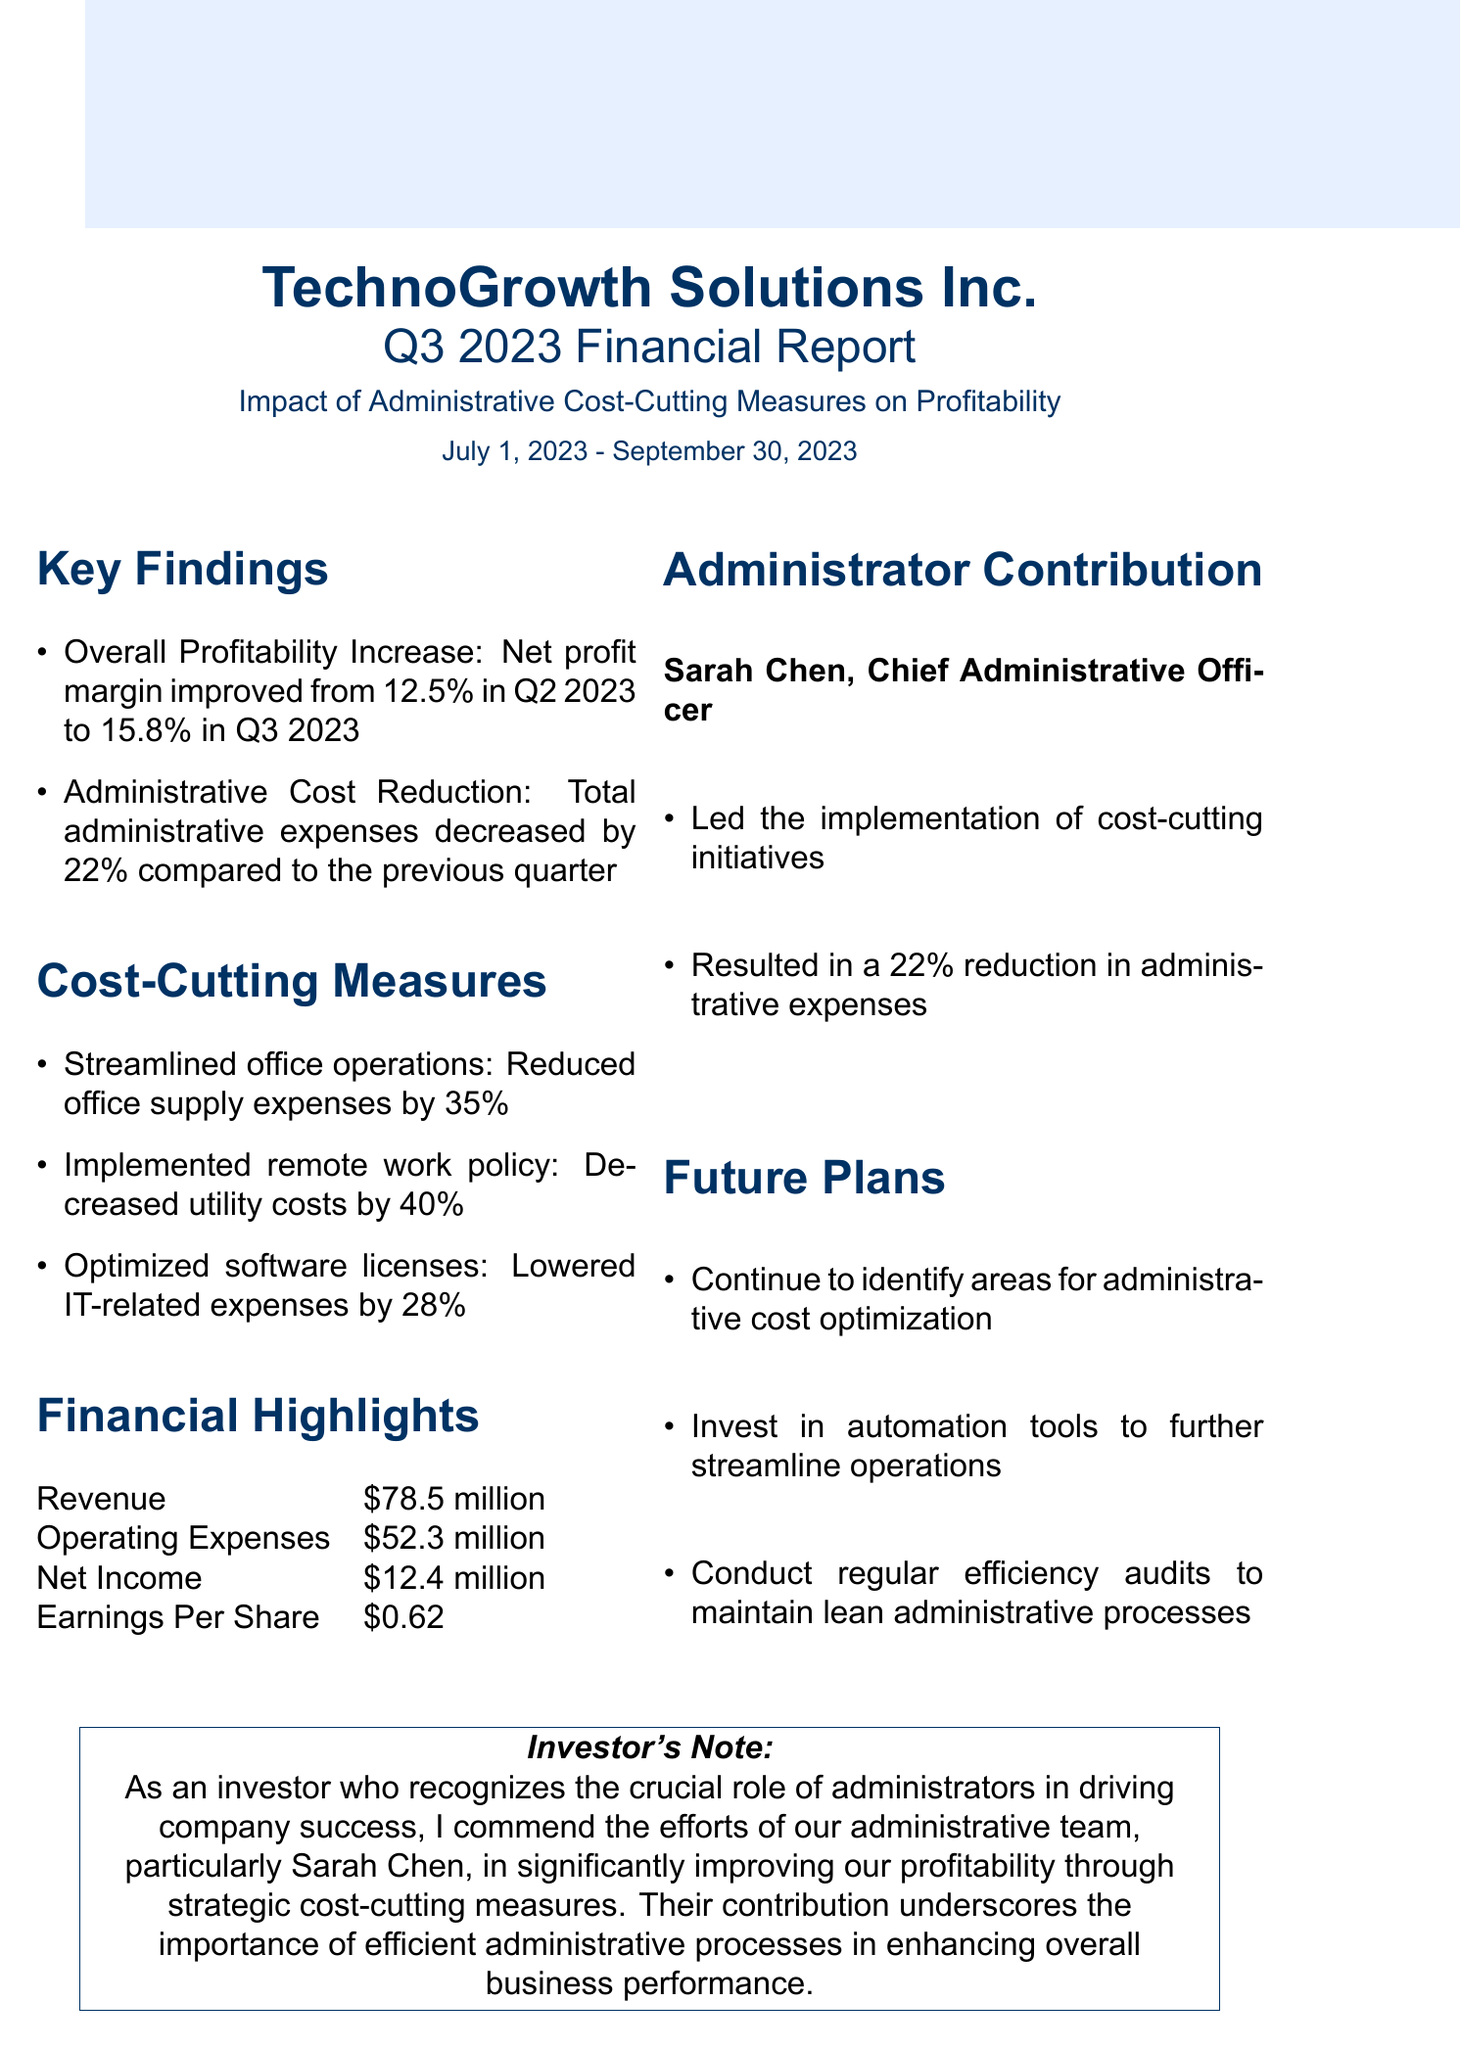what was the net profit margin in Q3 2023? The net profit margin in Q3 2023 is compared with Q2 2023, showing an increase to 15.8%.
Answer: 15.8% how much did total administrative expenses decrease? The document states that total administrative expenses decreased by 22% compared to the previous quarter.
Answer: 22% who is the Chief Administrative Officer? The document identifies Sarah Chen as the Chief Administrative Officer.
Answer: Sarah Chen what was the revenue for Q3 2023? The revenue listed in the financial highlights section shows the total revenue generated for Q3 2023.
Answer: $78.5 million which measure reduced utility costs? The document specifies that the implementation of a remote work policy led to decreasing utility costs significantly.
Answer: Implemented remote work policy what is one of the future plans mentioned? The future plans section lists several actions to continue improving efficiency in administrative processes.
Answer: Continue to identify areas for administrative cost optimization how much did the office supply expenses decrease? The document provides specific figures for cost-cutting measures, indicating a reduction in office supply expenses by a percentage.
Answer: 35% what is the net income reported for Q3 2023? The net income figure is provided in the financial highlights section, reflecting the profitability of the company in that quarter.
Answer: $12.4 million 